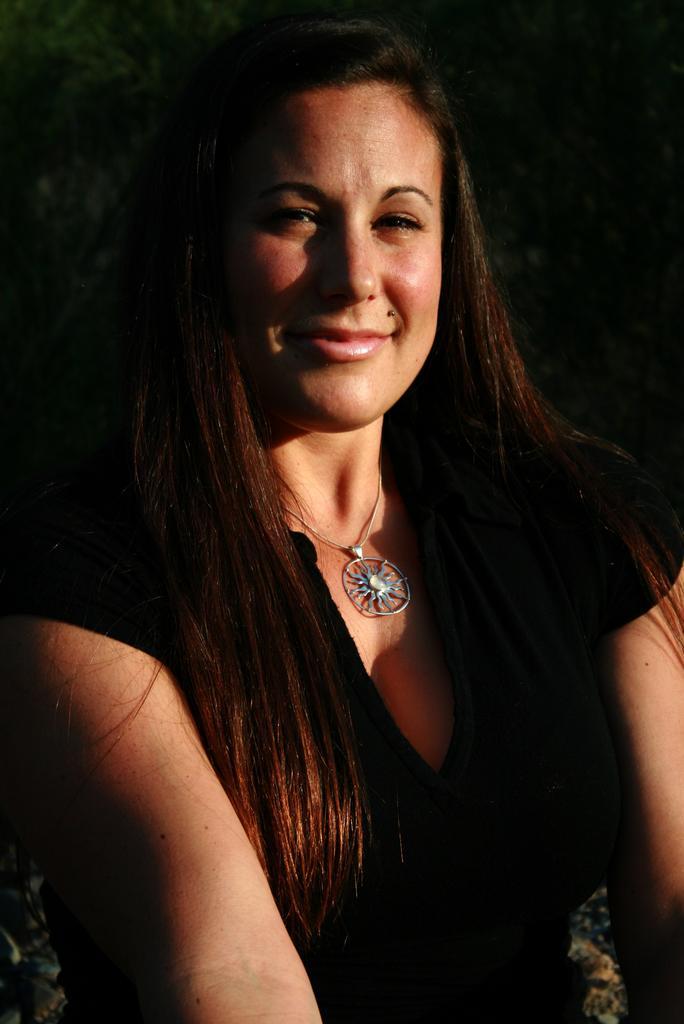In one or two sentences, can you explain what this image depicts? In the image,there is a woman she is wearing a black dress and she is smiling. There is a round locket chain in her neck and the background of the woman is black. 